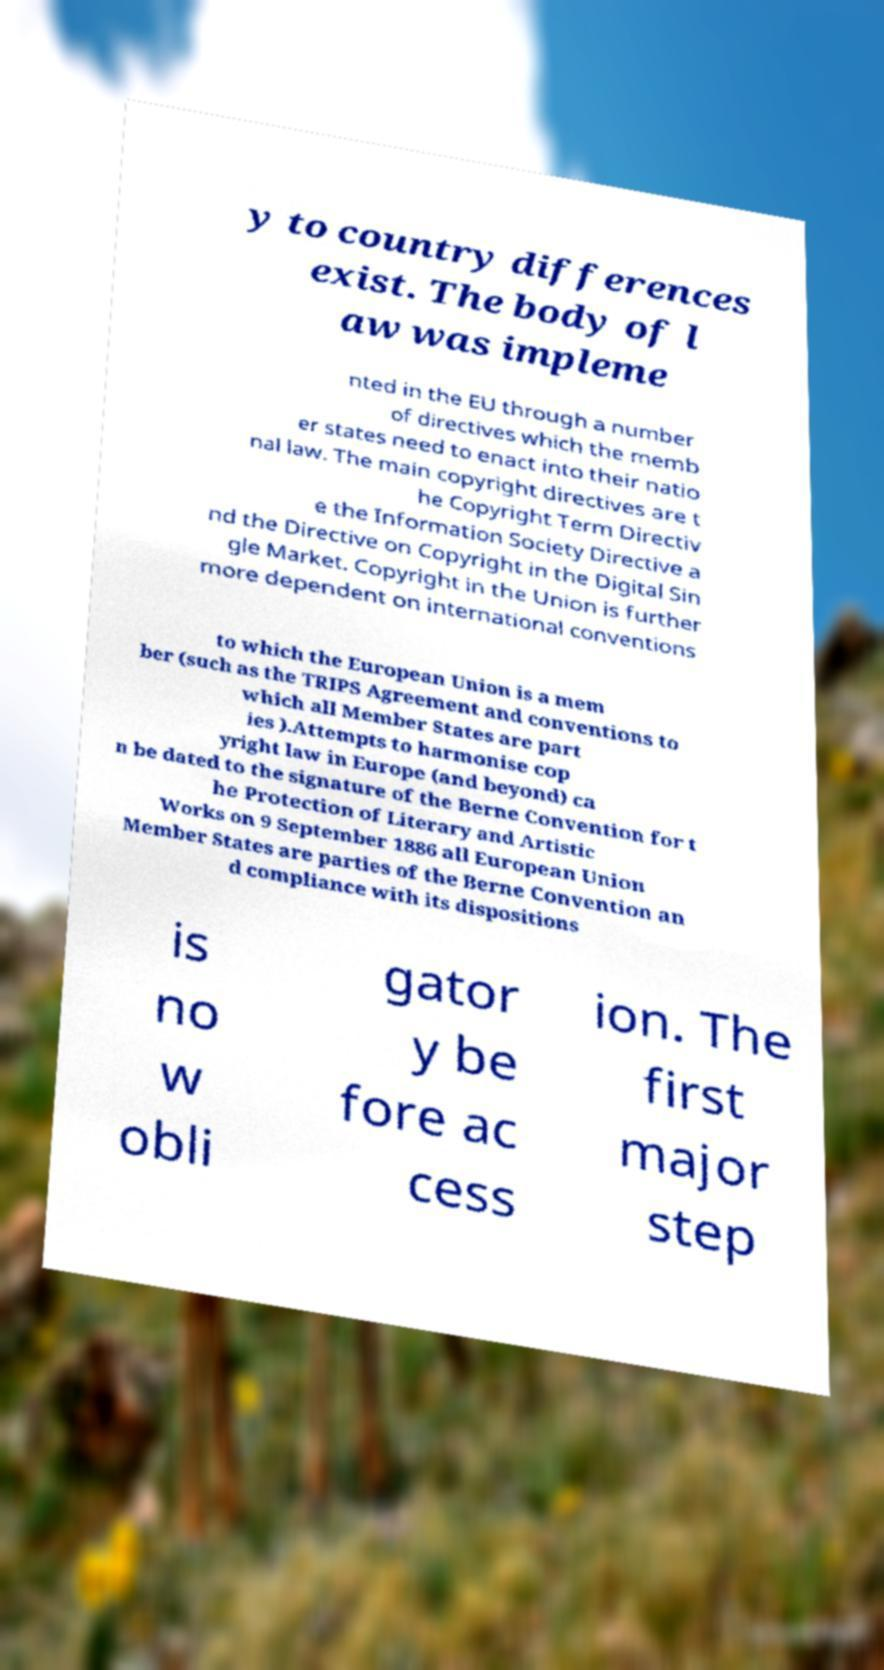I need the written content from this picture converted into text. Can you do that? y to country differences exist. The body of l aw was impleme nted in the EU through a number of directives which the memb er states need to enact into their natio nal law. The main copyright directives are t he Copyright Term Directiv e the Information Society Directive a nd the Directive on Copyright in the Digital Sin gle Market. Copyright in the Union is further more dependent on international conventions to which the European Union is a mem ber (such as the TRIPS Agreement and conventions to which all Member States are part ies ).Attempts to harmonise cop yright law in Europe (and beyond) ca n be dated to the signature of the Berne Convention for t he Protection of Literary and Artistic Works on 9 September 1886 all European Union Member States are parties of the Berne Convention an d compliance with its dispositions is no w obli gator y be fore ac cess ion. The first major step 